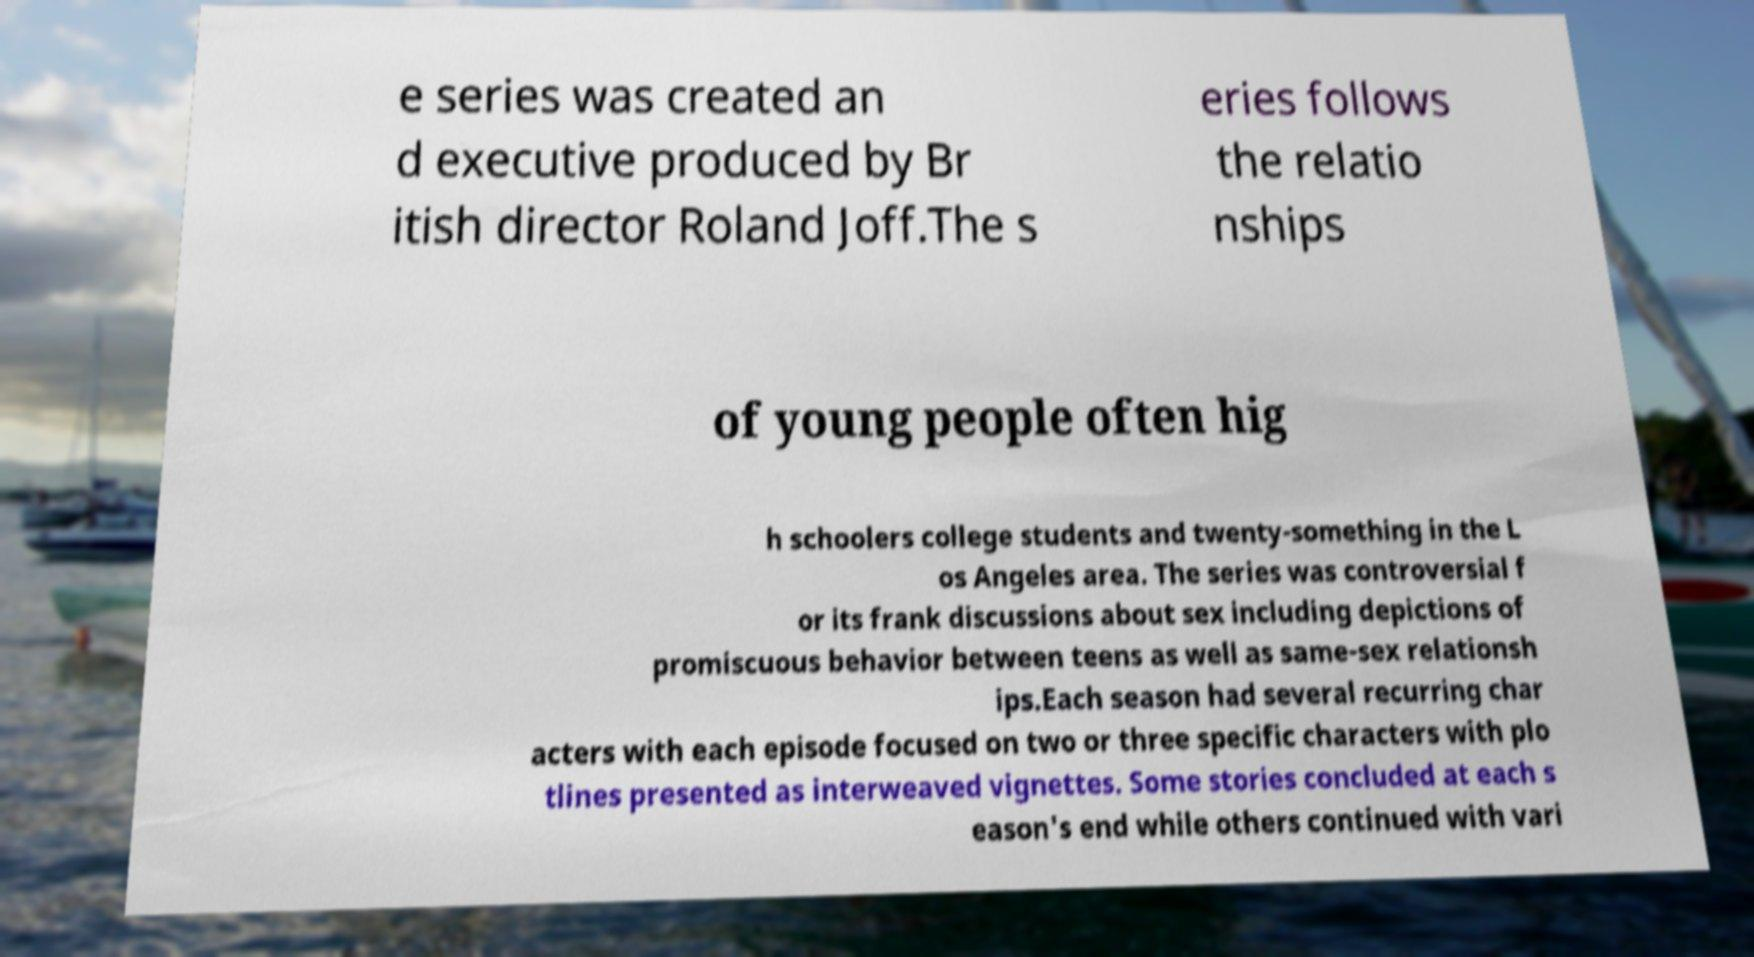For documentation purposes, I need the text within this image transcribed. Could you provide that? e series was created an d executive produced by Br itish director Roland Joff.The s eries follows the relatio nships of young people often hig h schoolers college students and twenty-something in the L os Angeles area. The series was controversial f or its frank discussions about sex including depictions of promiscuous behavior between teens as well as same-sex relationsh ips.Each season had several recurring char acters with each episode focused on two or three specific characters with plo tlines presented as interweaved vignettes. Some stories concluded at each s eason's end while others continued with vari 